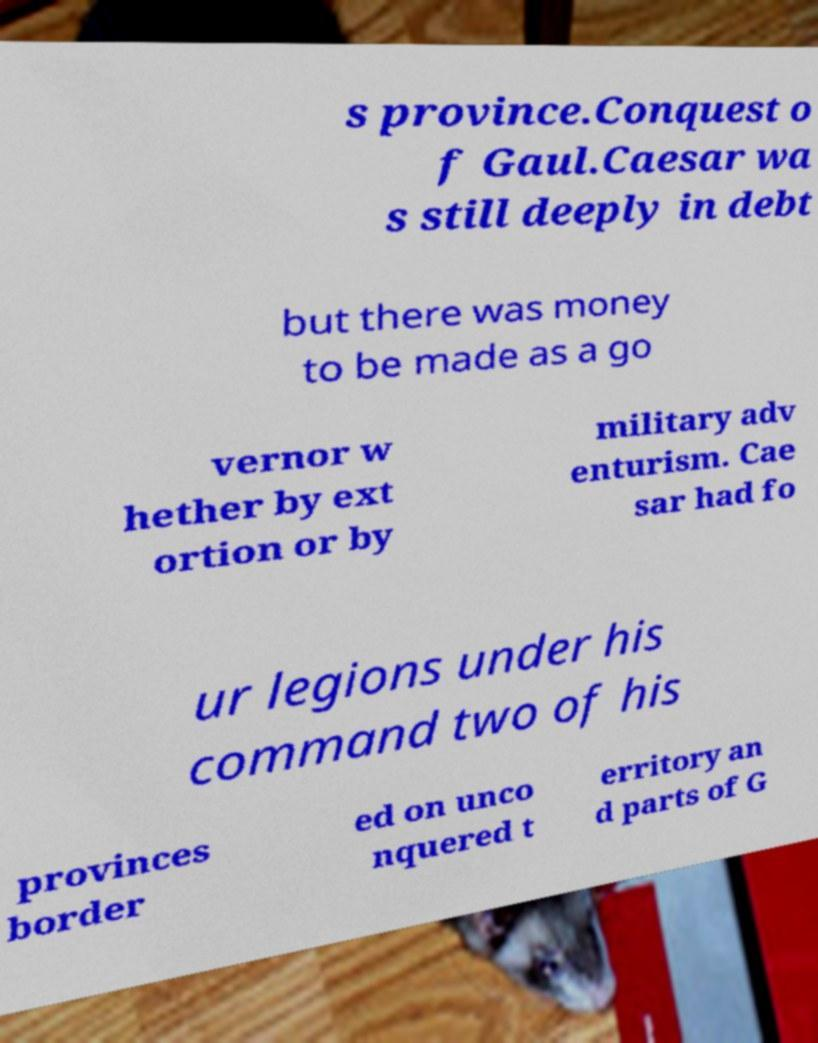Could you extract and type out the text from this image? s province.Conquest o f Gaul.Caesar wa s still deeply in debt but there was money to be made as a go vernor w hether by ext ortion or by military adv enturism. Cae sar had fo ur legions under his command two of his provinces border ed on unco nquered t erritory an d parts of G 